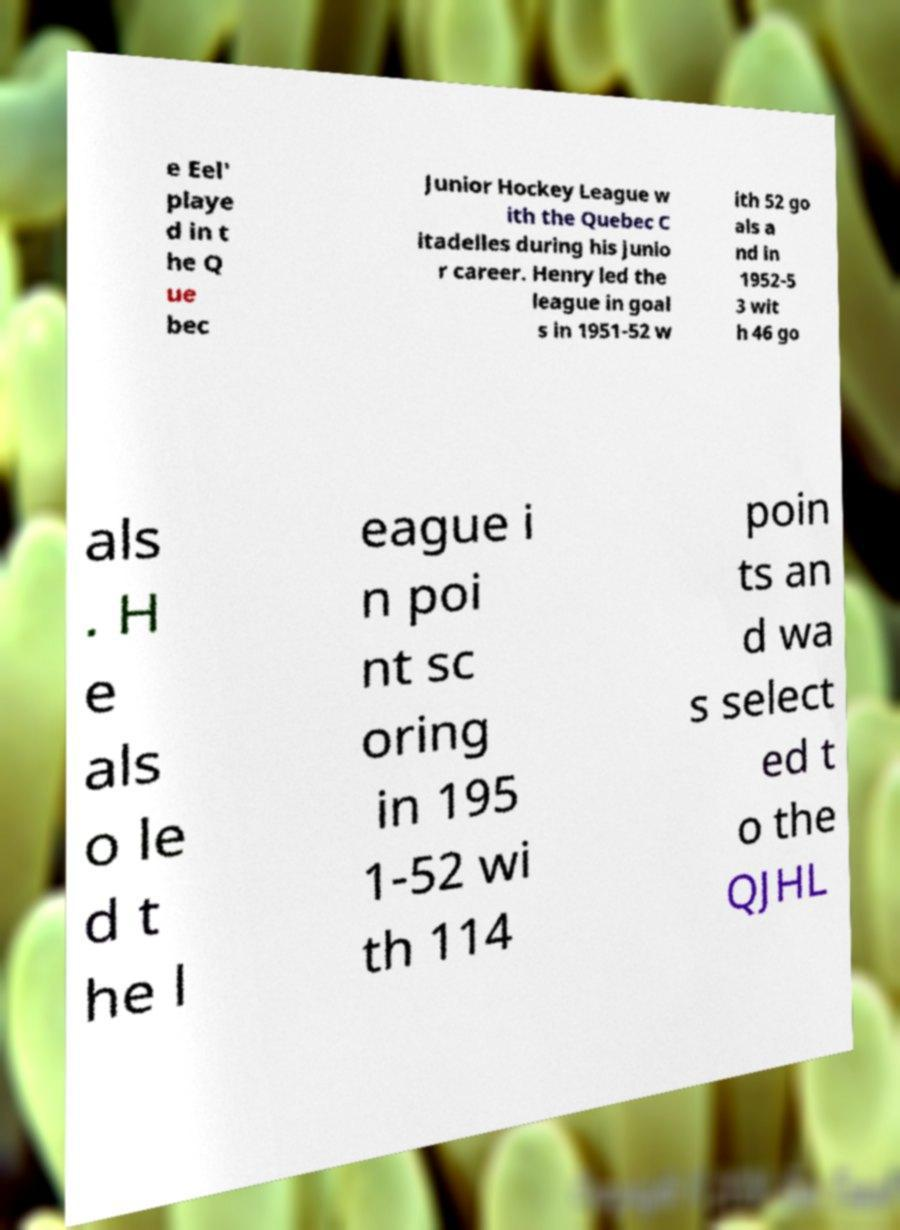Please read and relay the text visible in this image. What does it say? e Eel' playe d in t he Q ue bec Junior Hockey League w ith the Quebec C itadelles during his junio r career. Henry led the league in goal s in 1951-52 w ith 52 go als a nd in 1952-5 3 wit h 46 go als . H e als o le d t he l eague i n poi nt sc oring in 195 1-52 wi th 114 poin ts an d wa s select ed t o the QJHL 